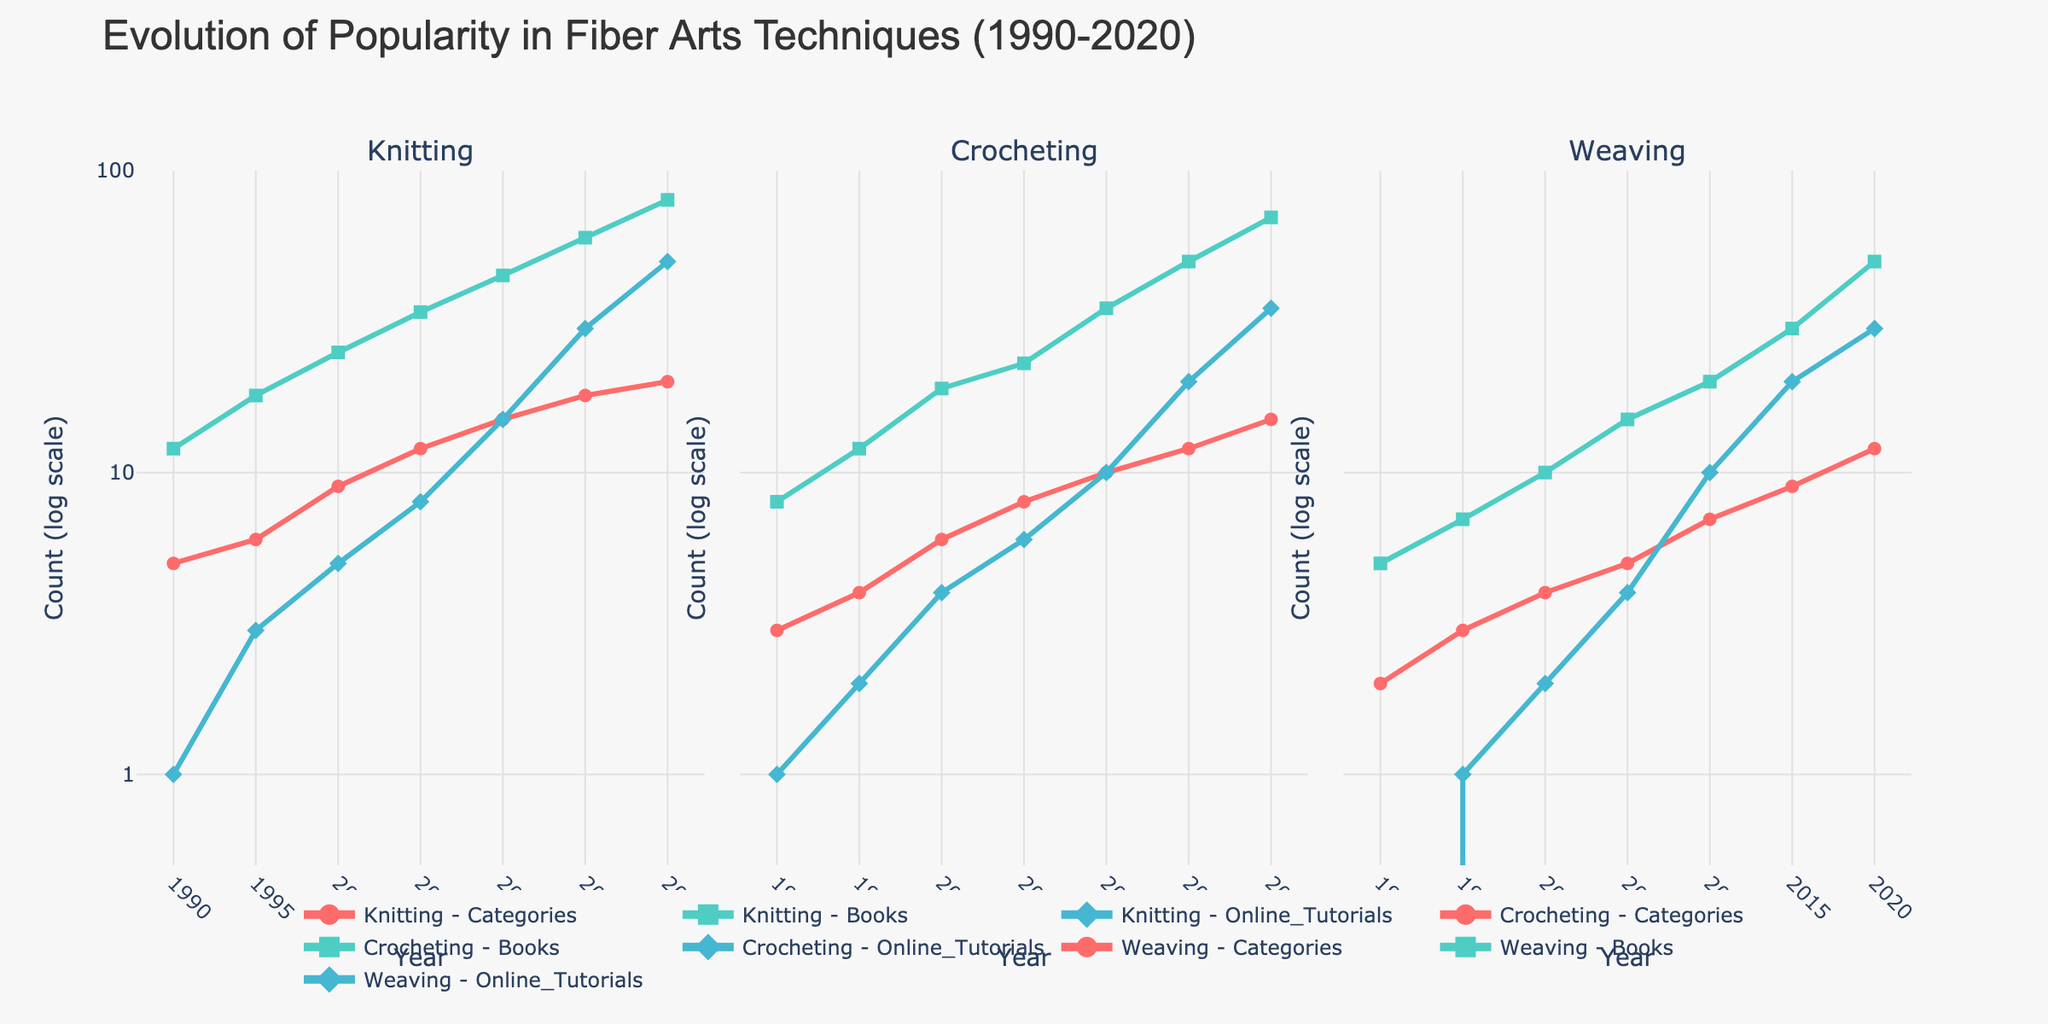What is the title of the figure? The title is prominently positioned at the top and helps provide context about the figure. By reading the top middle section, we can see the figure title.
Answer: Evolution of Popularity in Fiber Arts Techniques (1990-2020) How many subplots are there in the figure? By counting the number of distinct plots labeled with different techniques, we can determine that there are multiple subplots. The figure is divided into three sections, each representing a fiber art technique.
Answer: 3 Which fiber art technique has the highest count in 2020 for online tutorials? By looking at the data points for 2020 and comparing the values for the "Online Tutorials" category across Knitting, Crocheting, and Weaving, we observe that Knitting has the highest count.
Answer: Knitting Between 1990 and 2020, how many years show data points for Weaving books? By checking the x-axis labels for Weaving subplots and counting the corresponding y-axis data points for the "Books" category, we went through the figure and counted the years with visible data.
Answer: 7 What is the color used to represent "Books" across all techniques? The plotted lines and the legend use specific colors to differentiate between categories. By looking at the legend or examining the line colors, we identify the color used for "Books."
Answer: #4ECDC4 How much did the number of Sewing books increase from 2000 to 2020? While the question specifies a non-plotted technique ("Sewing"), we can infer the method of calculation using a different technique such as "Knitting" as an example. Subtract the value of "Knitting_Books" in 2000 from that in 2020, which is 80 - 25.
Answer: 55 What are the y-axis labels for each subplot, and why are they significant? All three subplots share the same y-axis labels. These labels use log scaling to manage large ranges in data by representing counts in logarithmic terms, making it easier to compare wide-ranging values. The labels are 1, 10, and 100.
Answer: 1, 10, 100 Which technique has the lowest starting point for categories in 1990? By looking at the data point on the left-most side of each subplot under "Categories" for the year 1990, we observe that Weaving has the lowest count.
Answer: Weaving What was the percentage increase in the number of "Crocheting Online Tutorials" from 2005 to 2020? First, get the values from the plot for the years 2005 (6) and 2020 (35). Calculate the increase: 35 - 6 = 29. Then determine the percentage increase: (29 / 6) * 100%.
Answer: 483.33% Which category saw the most significant overall increase across the timeline in "Knitting"? By visually tracking the slopes of each category in the Knitting subplot, we observe which line has the steepest increase. The "Online Tutorials" category shows the most significant rise from 1 in 1990 to 50 in 2020.
Answer: Online Tutorials 